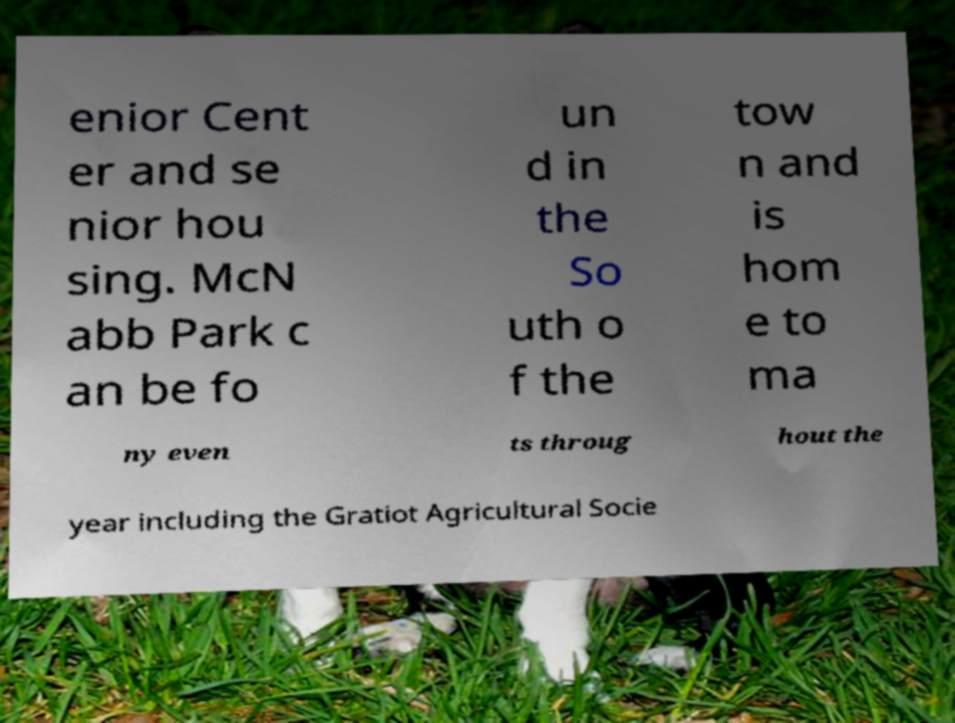What messages or text are displayed in this image? I need them in a readable, typed format. enior Cent er and se nior hou sing. McN abb Park c an be fo un d in the So uth o f the tow n and is hom e to ma ny even ts throug hout the year including the Gratiot Agricultural Socie 